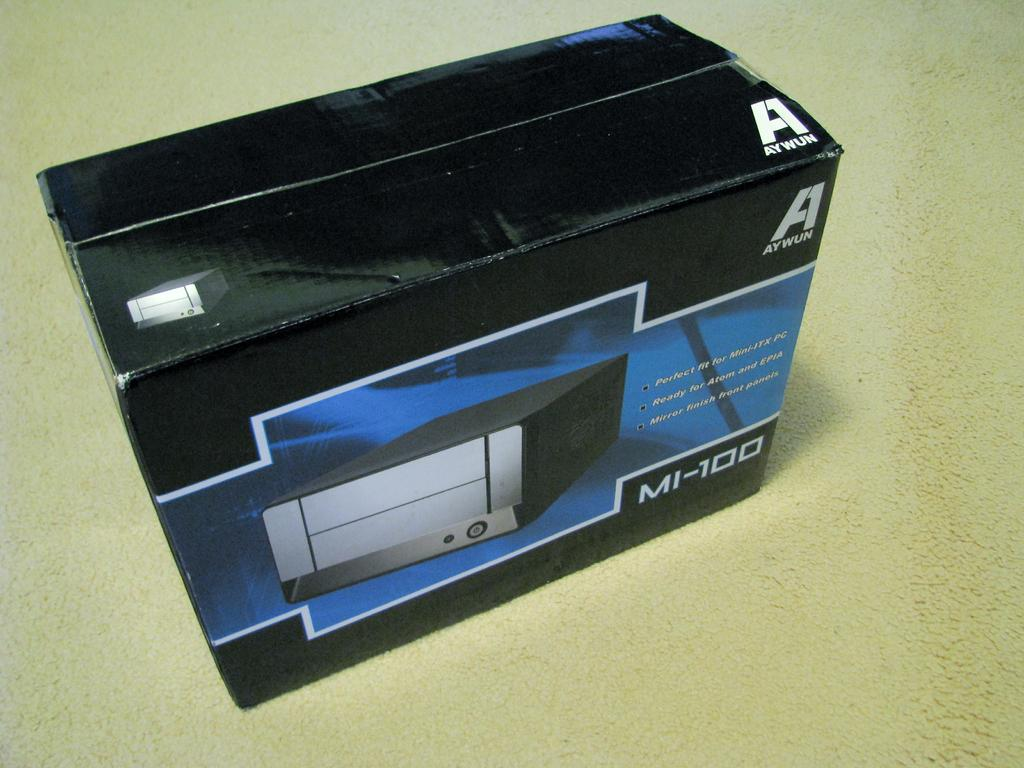<image>
Offer a succinct explanation of the picture presented. A box with the product MI-100 in it. 